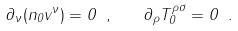Convert formula to latex. <formula><loc_0><loc_0><loc_500><loc_500>\partial _ { \nu } ( n _ { 0 } v ^ { \nu } ) = 0 \ , \quad \partial _ { \rho } T ^ { \rho \sigma } _ { 0 } = 0 \ .</formula> 